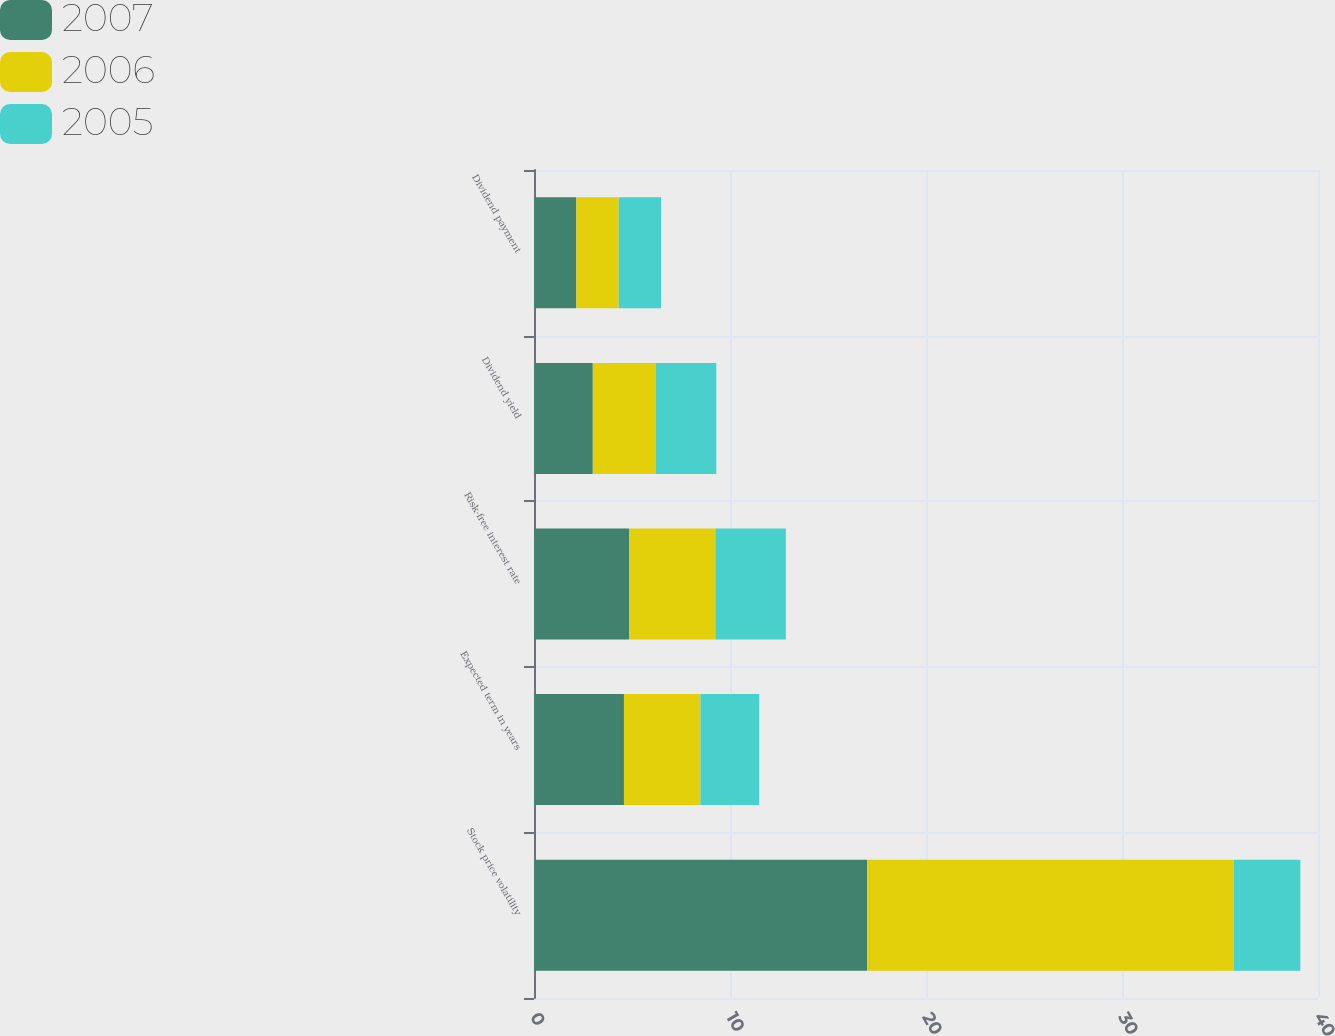Convert chart to OTSL. <chart><loc_0><loc_0><loc_500><loc_500><stacked_bar_chart><ecel><fcel>Stock price volatility<fcel>Expected term in years<fcel>Risk-free interest rate<fcel>Dividend yield<fcel>Dividend payment<nl><fcel>2007<fcel>17<fcel>4.59<fcel>4.85<fcel>3<fcel>2.16<nl><fcel>2006<fcel>18.7<fcel>3.9<fcel>4.4<fcel>3.2<fcel>2.16<nl><fcel>2005<fcel>3.4<fcel>3<fcel>3.6<fcel>3.1<fcel>2.16<nl></chart> 